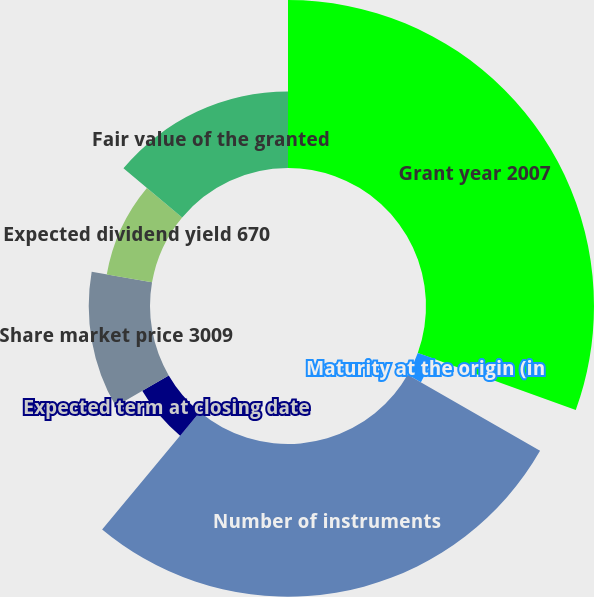Convert chart. <chart><loc_0><loc_0><loc_500><loc_500><pie_chart><fcel>Grant year 2007<fcel>Maturity at the origin (in<fcel>Number of instruments<fcel>Expected term at closing date<fcel>Share market price 3009<fcel>Expected dividend yield 670<fcel>Fair value of the granted<fcel>Fair value of the plan as of<nl><fcel>30.52%<fcel>2.78%<fcel>27.74%<fcel>5.57%<fcel>11.13%<fcel>8.35%<fcel>13.91%<fcel>0.0%<nl></chart> 